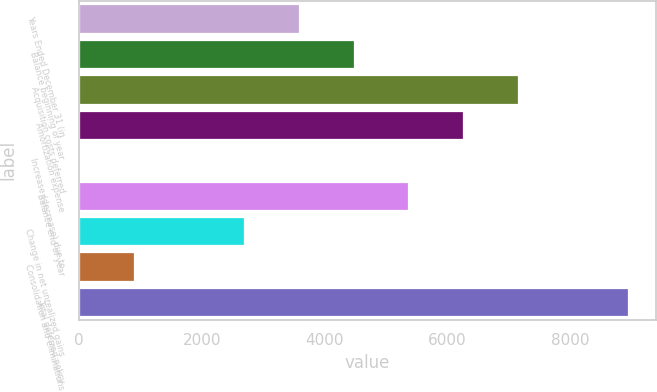Convert chart to OTSL. <chart><loc_0><loc_0><loc_500><loc_500><bar_chart><fcel>Years Ended December 31 (in<fcel>Balance beginning of year<fcel>Acquisition costs deferred<fcel>Amortization expense<fcel>Increase (decrease) due to<fcel>Balance end of year<fcel>Change in net unrealized gains<fcel>Consolidation and eliminations<fcel>Total deferred policy<nl><fcel>3576.6<fcel>4470<fcel>7150.2<fcel>6256.8<fcel>3<fcel>5363.4<fcel>2683.2<fcel>896.4<fcel>8937<nl></chart> 